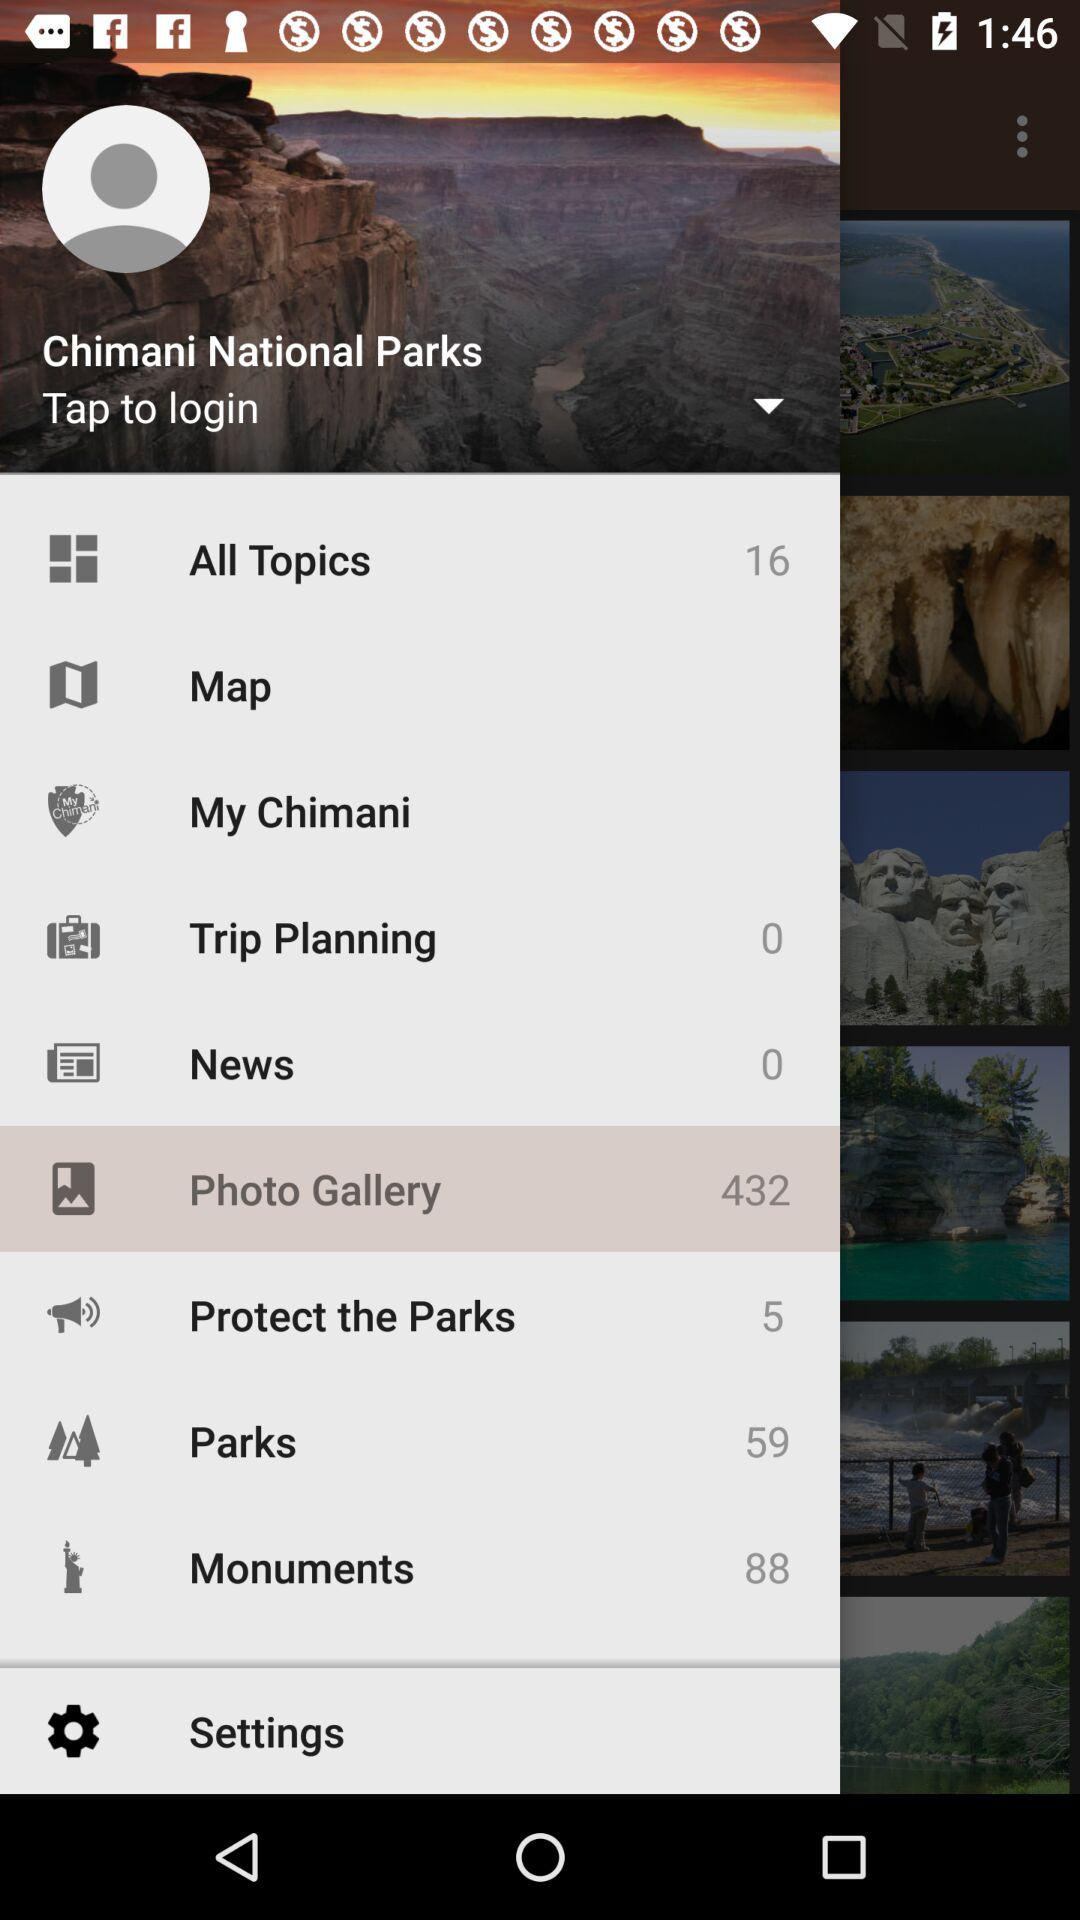Which item has been selected? The selected item is "Photo Gallery". 